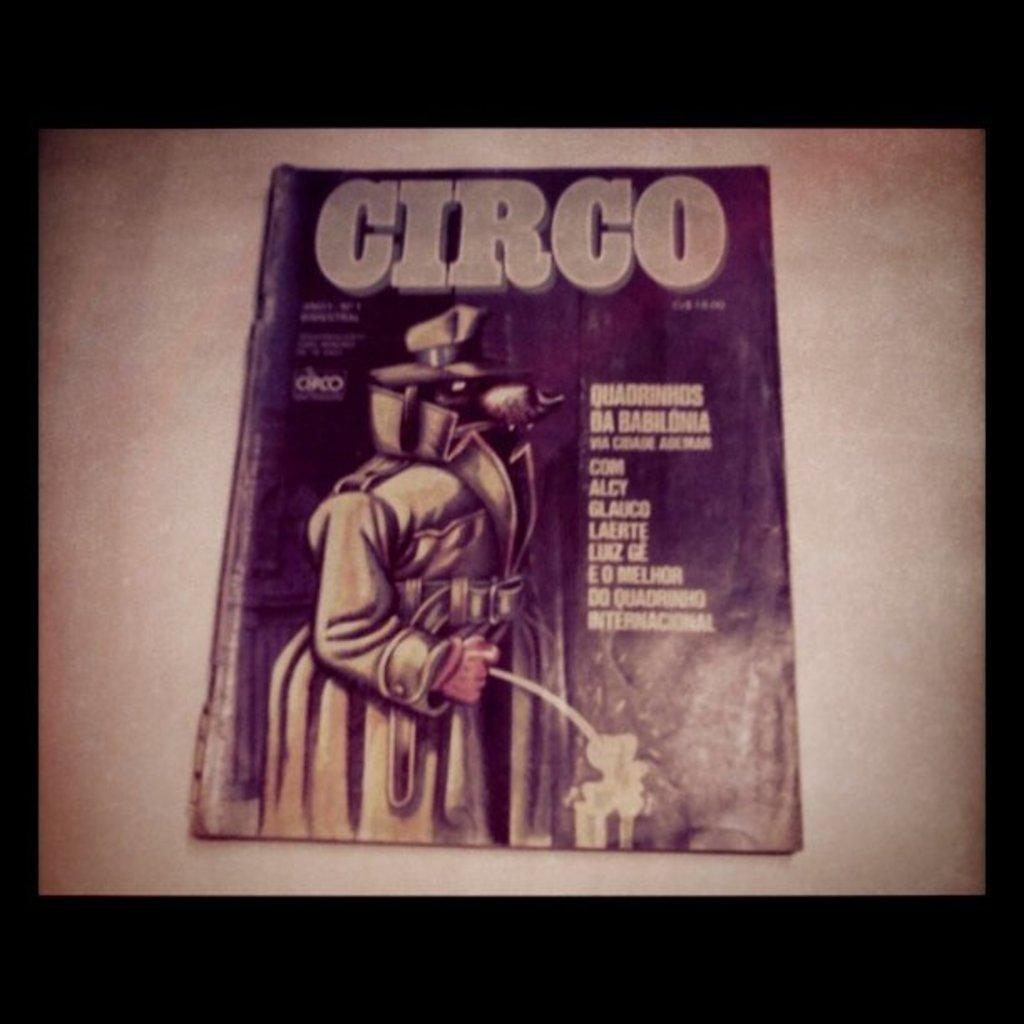What piece of furniture is present in the image? There is a table in the image. What object is placed on the table? There is a magazine on the table. What can be found on the magazine? There is text and a picture on the magazine. What season is depicted in the image? There is no season depicted in the image, as it only features a table, a magazine, and the contents of the magazine. 